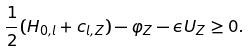Convert formula to latex. <formula><loc_0><loc_0><loc_500><loc_500>\frac { 1 } { 2 } ( H _ { 0 , l } + c _ { l , Z } ) - \varphi _ { Z } - \epsilon U _ { Z } \geq 0 .</formula> 